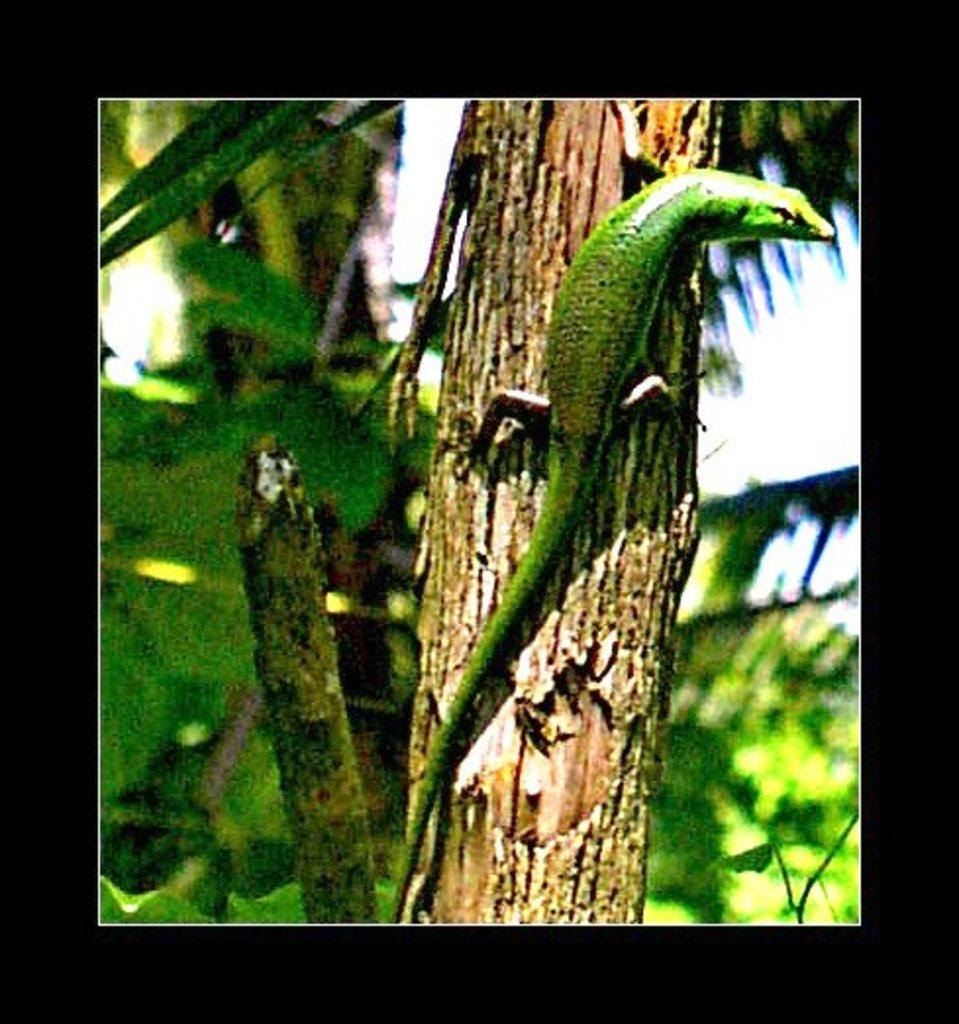What type of animal is on the tree in the image? There is a reptile on the tree in the image. What can be seen behind the tree? There are leaves and branches behind the tree. What is visible in the background of the image? The sky is visible in the background of the image. What color is the crayon being used by the reptile in the image? There is no crayon present in the image, as it features a reptile on a tree with leaves and branches, and a visible sky in the background. 